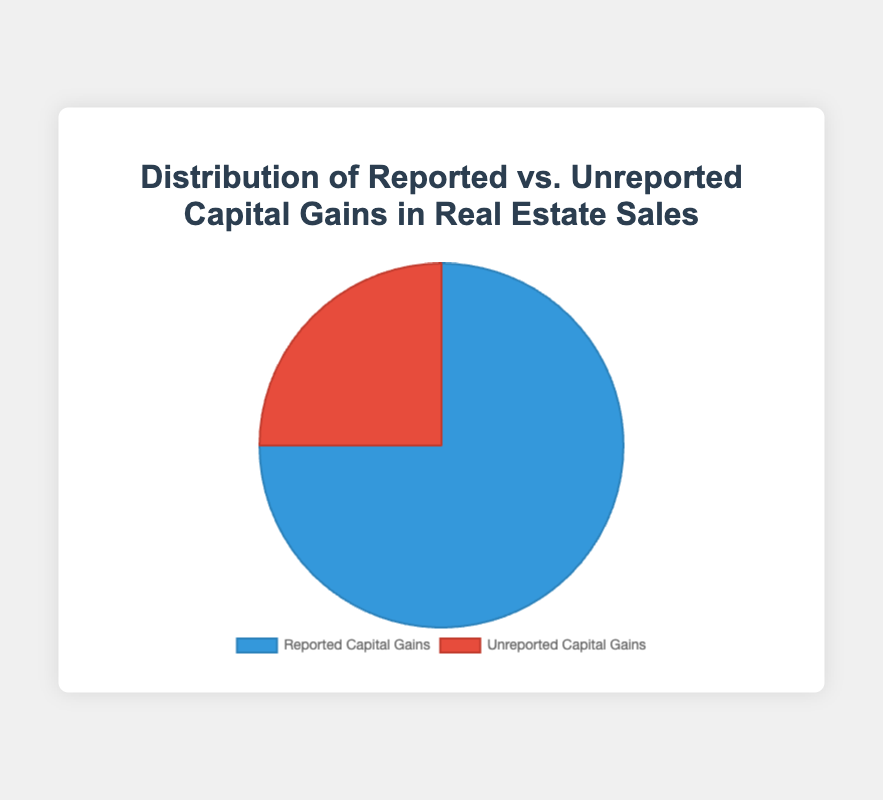How much percentage of total capital gains is reported? The pie chart shows the data for reported and unreported capital gains. From the chart, reported capital gains constitute 75%.
Answer: 75% What is the percentage of unreported capital gains compared to reported ones? The percentage of unreported capital gains is 25%, and the percentage of reported ones is 75%. Dividing the unreported percentage by the reported percentage and multiplying by 100 gives (25 / 75) * 100 = 33.33%.
Answer: 33.33% Which category has a higher percentage, reported or unreported capital gains? By comparing the values in the chart, reported capital gains at 75% are higher than unreported capital gains at 25%.
Answer: Reported capital gains What is the total percentage of capital gains displayed in the chart? The pie chart includes both reported and unreported capital gains, which are 75% and 25%, respectively. Summing these gives 75% + 25% = 100%.
Answer: 100% What is the difference in percentage points between reported and unreported capital gains? The reported capital gains are 75%, and the unreported ones are 25%. Subtracting the unreported percentage from the reported percentage gives 75% - 25% = 50%.
Answer: 50% What colors represent reported and unreported capital gains? Reported capital gains are represented by the color blue, and unreported capital gains are represented by the color red.
Answer: Blue for reported and red for unreported If we were to only consider the gain distribution, which part would constitute three-fourths? Given that reported capital gains are 75%, they represent three-fourths of the entire pie chart.
Answer: Reported capital gains By what factor is the reported percentage larger than the unreported percentage? The reported percentage is 75%, and the unreported percentage is 25%. Dividing the reported by the unreported gives 75 / 25 = 3. This means reported is 3 times larger.
Answer: 3 If the total monetary value of capital gains is $1,000,000, how much is reported? If 75% of the total monetary value is reported, then 75% of $1,000,000 is 0.75 * $1,000,000 = $750,000.
Answer: $750,000 What percentage of capital gains remains unreported if the market were to aim for full compliance? To achieve full compliance, the unreported capital gains would need to be 0%, as all should be reported.
Answer: 0% 